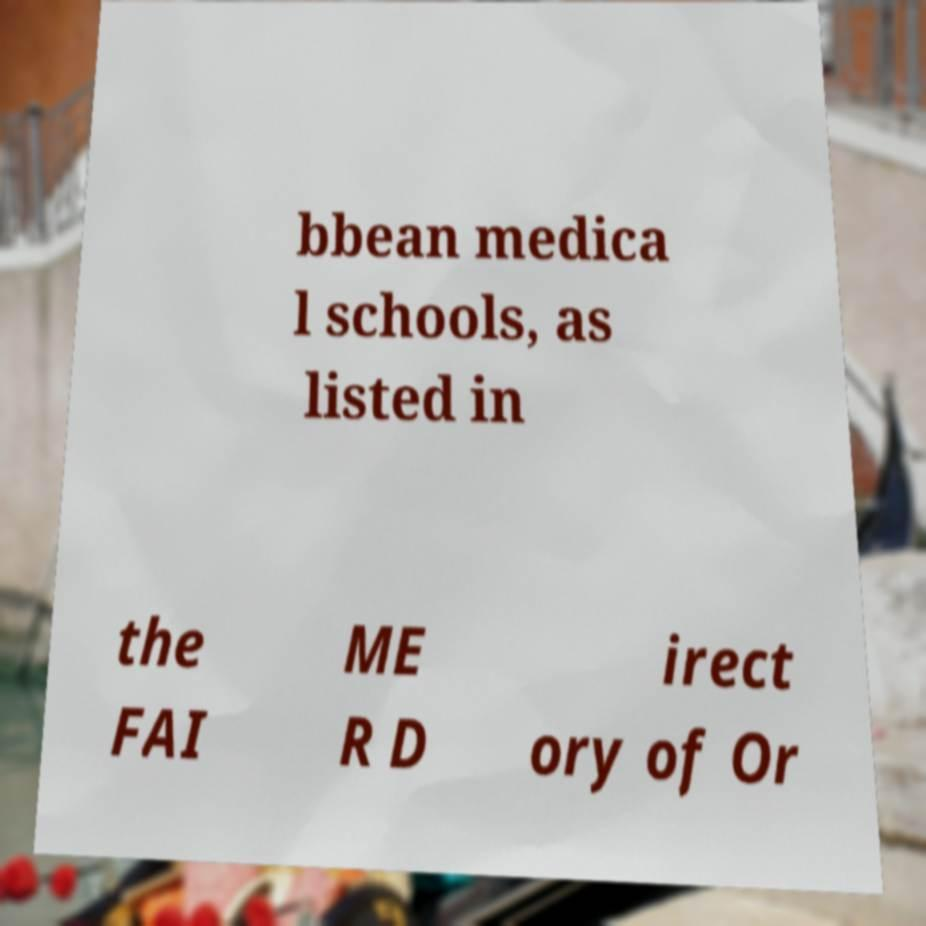There's text embedded in this image that I need extracted. Can you transcribe it verbatim? bbean medica l schools, as listed in the FAI ME R D irect ory of Or 